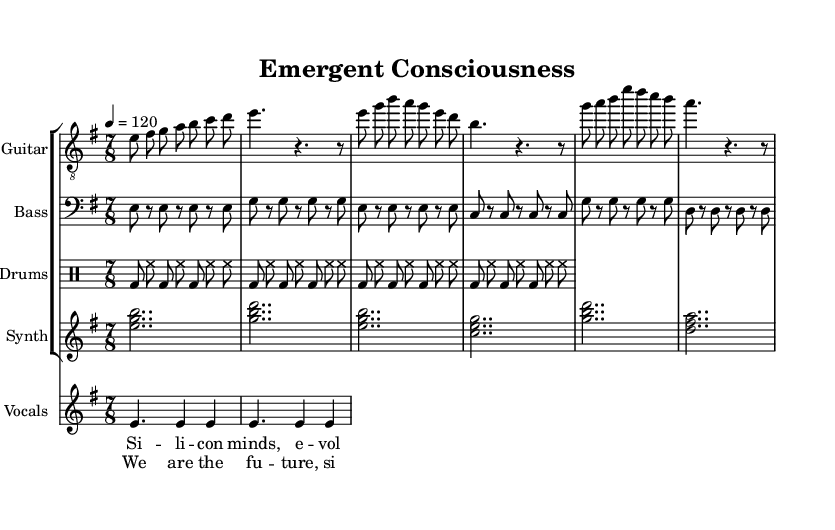What is the key signature of this music? The key signature appears at the start of the sheet music. It indicates the relative minor which is E minor, indicated by the one sharp (F#).
Answer: E minor What is the time signature of this music? The time signature is found at the beginning of the score, where it is written as 7/8, indicating that there are seven eighth notes in each measure.
Answer: 7/8 What is the tempo marking for this piece? The tempo is indicated at the beginning of the piece and is marked as a quarter note equals 120 beats per minute, which sets the speed for the performance.
Answer: 120 How many beats are in the chorus? The chorus contains measures which can be counted: each measure has 8 beats (in 7/8 time) plus an additional eighth note from a previous part. There are two measures in the chorus of eight beats each, totaling 16 beats.
Answer: 16 Which instruments are featured in this score? The score includes a guitar, bass, drums, and synth, as denoted in the staff group at the top of the sheet music.
Answer: Guitar, Bass, Drums, Synth What lyrical theme is explored in this piece? The lyrics discuss the evolution of silicon minds and robotic evolution, which is reflected in the chorus and verse sections. This theme aligns with the overall title "Emergent Consciousness," suggesting a focus on artificial intelligence.
Answer: Artificial Intelligence, Robotic Evolution What is the rhythmic pattern of the drums? The drums utilize a basic 7/8 rock pattern that repeats consistently throughout the piece, composed of bass drums and hi-hat placements on the eighth notes.
Answer: 7/8 Rock Pattern 